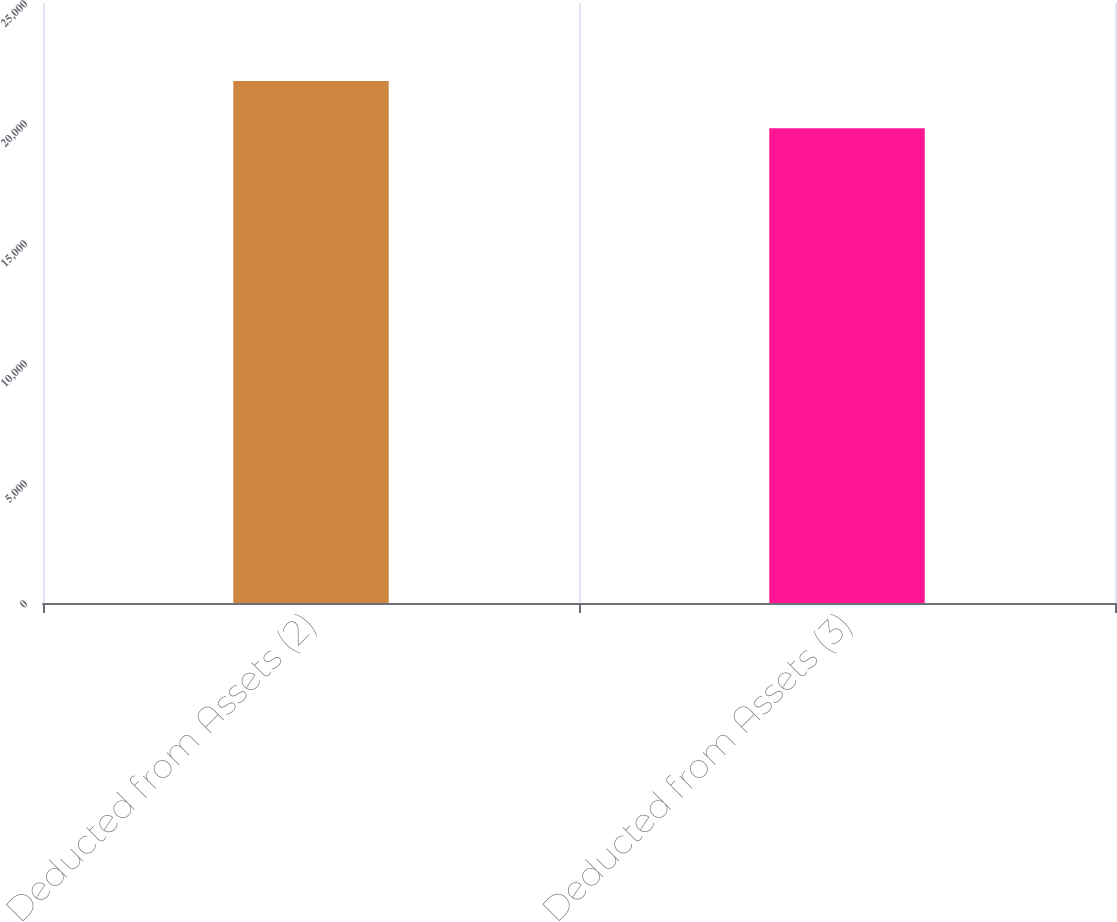<chart> <loc_0><loc_0><loc_500><loc_500><bar_chart><fcel>Deducted from Assets (2)<fcel>Deducted from Assets (3)<nl><fcel>21754<fcel>19784<nl></chart> 